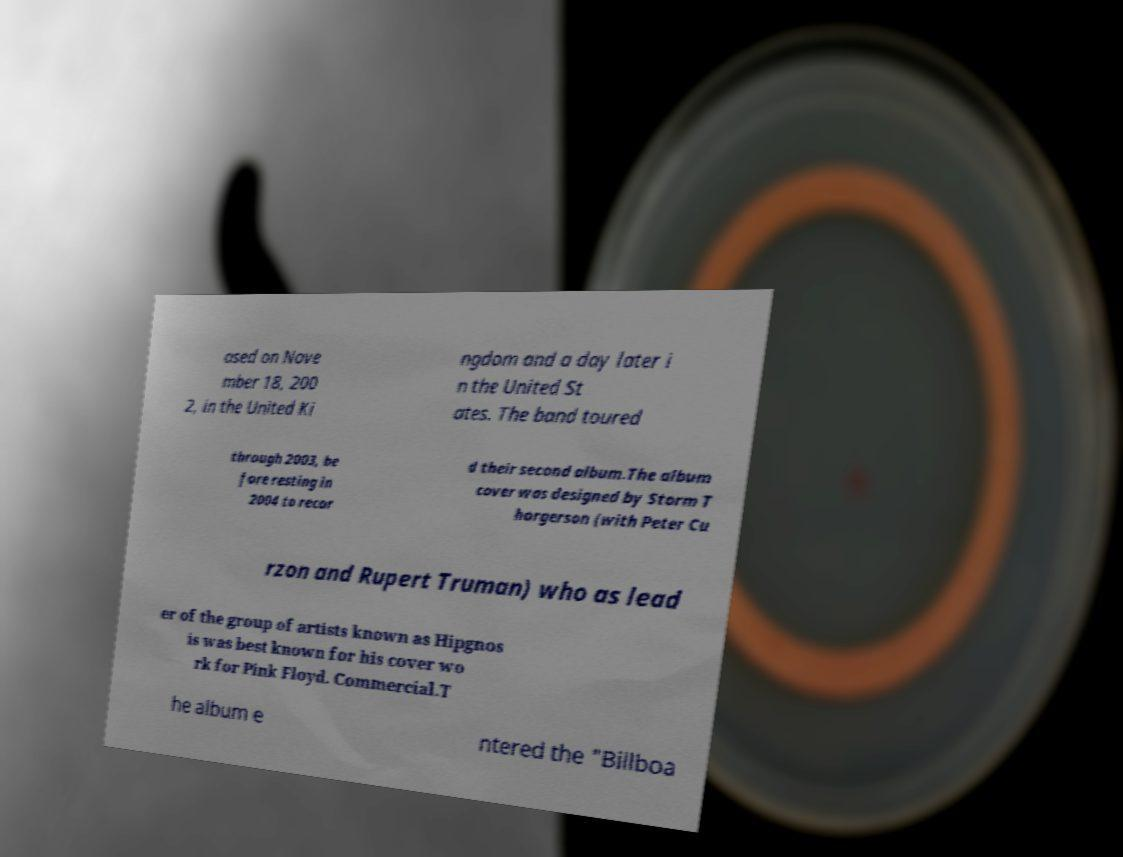There's text embedded in this image that I need extracted. Can you transcribe it verbatim? ased on Nove mber 18, 200 2, in the United Ki ngdom and a day later i n the United St ates. The band toured through 2003, be fore resting in 2004 to recor d their second album.The album cover was designed by Storm T horgerson (with Peter Cu rzon and Rupert Truman) who as lead er of the group of artists known as Hipgnos is was best known for his cover wo rk for Pink Floyd. Commercial.T he album e ntered the "Billboa 